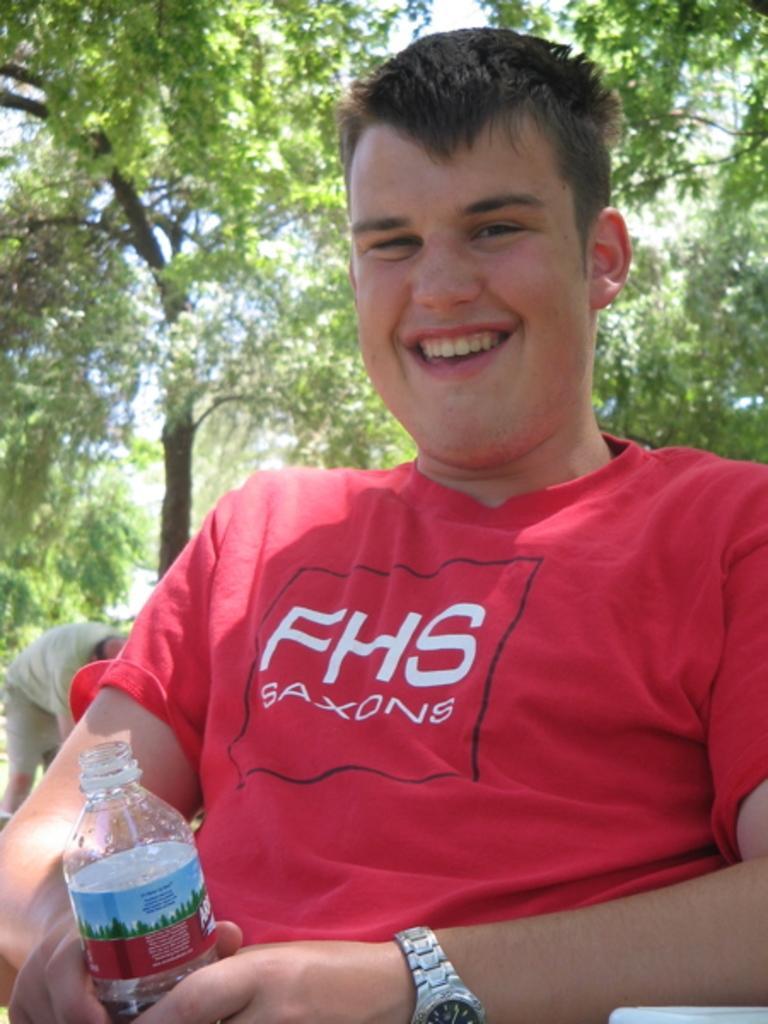Could you give a brief overview of what you see in this image? This picture shows a man seated on the chair and holding a bottle in his hand and we see couple of trees 